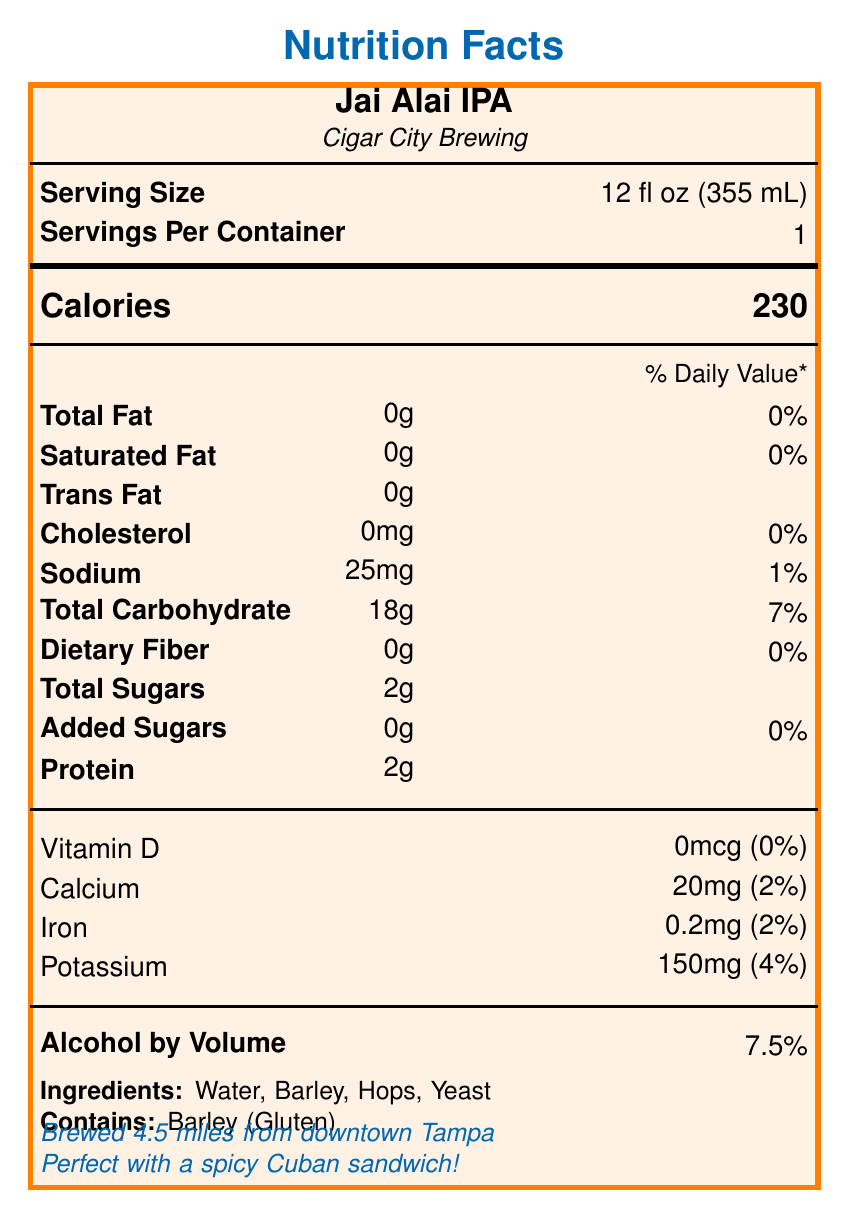what is the serving size for Jai Alai IPA? The document specifies the serving size as "12 fl oz (355 mL)" in the Serving Size section.
Answer: 12 fl oz (355 mL) how many calories are in a single serving of Jai Alai IPA? The document lists "230" calories under the Calories heading.
Answer: 230 what is the amount of total fat in Jai Alai IPA? The document shows "0g" as the amount of Total Fat in the Nutrition Information section.
Answer: 0g how much sodium does Jai Alai IPA contain? The document indicates that Jai Alai IPA contains "25mg" of sodium.
Answer: 25mg what is the percentage daily value of potassium in Jai Alai IPA? The document states that Jai Alai IPA has 150mg of potassium, which is 4% of the daily value.
Answer: 4% what are the ingredients of Jai Alai IPA? The document lists the ingredients as "Water, Barley, Hops, Yeast".
Answer: Water, Barley, Hops, Yeast which nearby attractions are mentioned in the document? The document mentions three nearby attractions: "Raymond James Stadium", "International Plaza and Bay Street", and "Tampa International Airport".
Answer: Raymond James Stadium, International Plaza and Bay Street, Tampa International Airport what is the alcohol by volume (ABV) percentage of Jai Alai IPA? The document states that the Alcohol by Volume is "7.5%".
Answer: 7.5% which food pairing is recommended with Jai Alai IPA? A. Chicken Wings B. Grilled Gulf Shrimp C. Caesar Salad D. Pepperoni Pizza The document suggests food pairings including "Spicy Cuban sandwich", "Grilled Gulf shrimp", and "Key lime pie".
Answer: B. Grilled Gulf Shrimp which vitamin is not present in Jai Alai IPA? A. Vitamin A B. Vitamin B12 C. Vitamin C D. Vitamin D The document specifies "0mcg" for Vitamin D, meaning it is not present in the beer.
Answer: D. Vitamin D is Jai Alai IPA gluten-free? The document lists barley as an ingredient and states "Contains: Barley (Gluten)", indicating it is not gluten-free.
Answer: No summarize the nutritional and additional information provided about Jai Alai IPA in the document. This summary mentions the main nutritional facts, ingredients, locality, food pairings, and the brewery's sustainable practices as described in the document.
Answer: Jai Alai IPA from Cigar City Brewing has a serving size of 12 fl oz (355 mL) with 230 calories per serving. It contains no fat or cholesterol, 25mg of sodium, 18g of carbohydrates, 2g of total sugars, no added sugars, and 2g of protein. It also has 0mcg of Vitamin D, 20mg of calcium, 0.2mg of iron, and 150mg of potassium. The beer has an alcohol by volume (ABV) of 7.5%. Ingredients include water, barley, hops, and yeast, with barley as a source of gluten. Brewed in Tampa, the brewery's location is 4.5 miles from downtown, and it pairs well with food like a spicy Cuban sandwich, grilled Gulf shrimp, and Key lime pie. The brewery participates in sustainable practices like using locally sourced ingredients and recycling spent grain. what is the distance from downtown Tampa to the brewery? The document notes that the brewery is "4.5 miles from downtown Tampa".
Answer: 4.5 miles how much total carbohydrate is in Jai Alai IPA? The document lists "18g" for Total Carbohydrate in the Nutrition Information section.
Answer: 18g does Jai Alai IPA contain any added sugars? The document specifies "0g" of Added Sugars in the Nutrition Information section.
Answer: No how much calcium is in a serving of Jai Alai IPA? The document shows that there are "20mg" of calcium in one serving.
Answer: 20mg what sustainable practice is mentioned regarding spent grains? The document states that Cigar City Brewing participates in "a spent grain recycling program with local farmers."
Answer: Recycling with local farmers how far is Raymond James Stadium from the brewery? The document does not provide the specific distance from the brewery to Raymond James Stadium.
Answer: Not enough information 